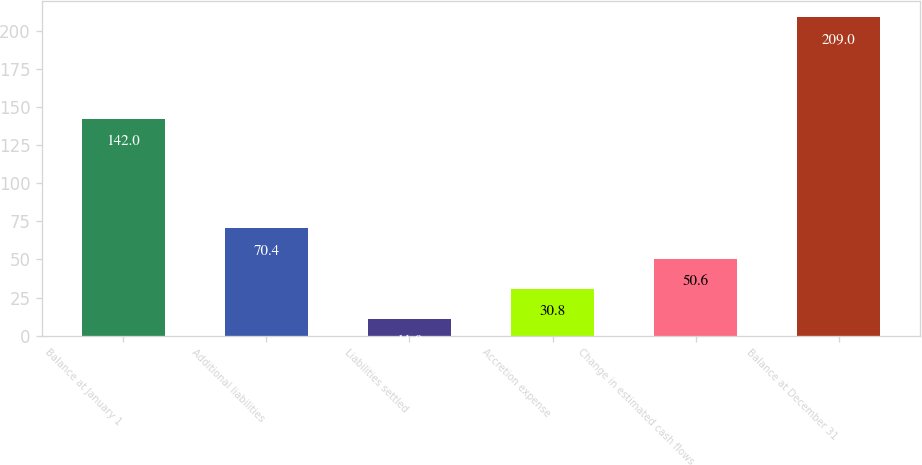Convert chart. <chart><loc_0><loc_0><loc_500><loc_500><bar_chart><fcel>Balance at January 1<fcel>Additional liabilities<fcel>Liabilities settled<fcel>Accretion expense<fcel>Change in estimated cash flows<fcel>Balance at December 31<nl><fcel>142<fcel>70.4<fcel>11<fcel>30.8<fcel>50.6<fcel>209<nl></chart> 